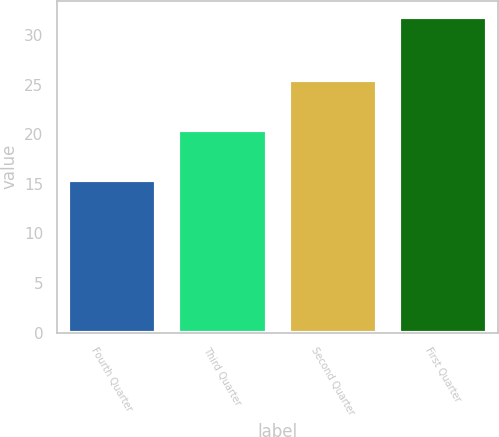Convert chart to OTSL. <chart><loc_0><loc_0><loc_500><loc_500><bar_chart><fcel>Fourth Quarter<fcel>Third Quarter<fcel>Second Quarter<fcel>First Quarter<nl><fcel>15.36<fcel>20.42<fcel>25.5<fcel>31.88<nl></chart> 